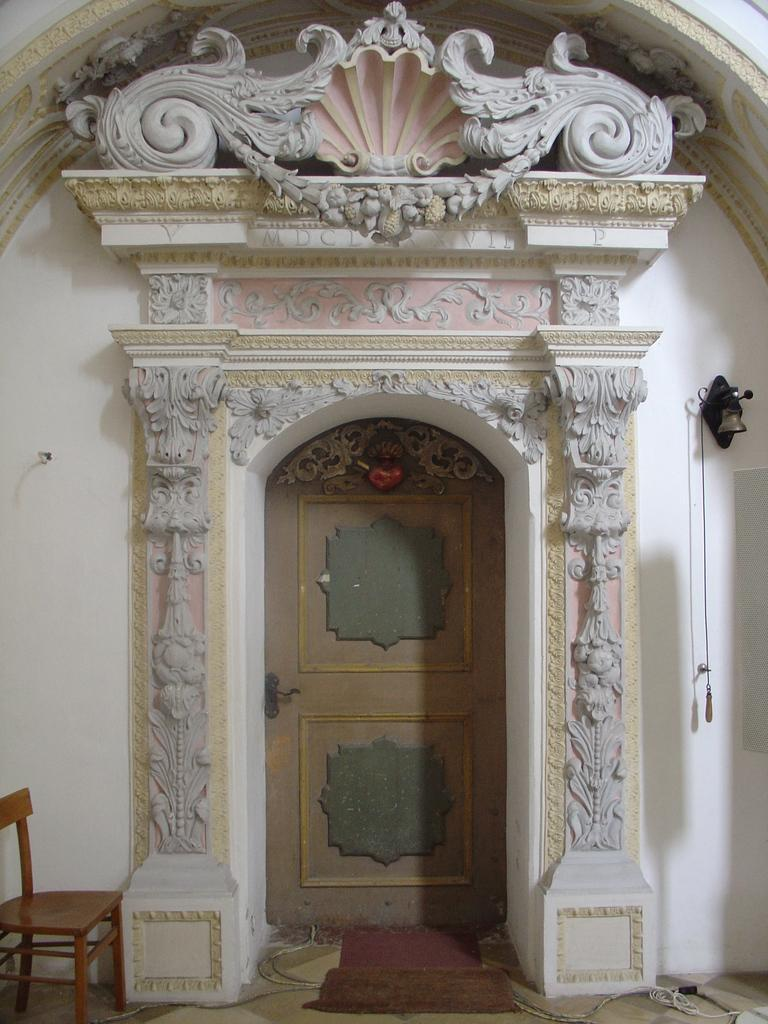What is located in the middle of the image? There is a door in the middle of the image. What can be seen on the right side of the image? There is a bell and a wall on the right side of the image. Where is the chair located in the image? The chair is at the left bottom of the image. What type of cannon is present on the left side of the image? There is no cannon present in the image. What boundary is depicted on the right side of the image? There is no boundary depicted on the right side of the image. 